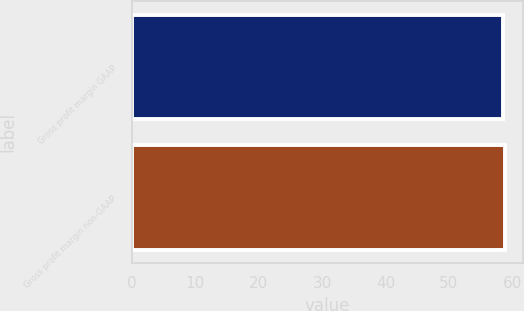Convert chart. <chart><loc_0><loc_0><loc_500><loc_500><bar_chart><fcel>Gross profit margin GAAP<fcel>Gross profit margin non-GAAP<nl><fcel>58.6<fcel>58.8<nl></chart> 